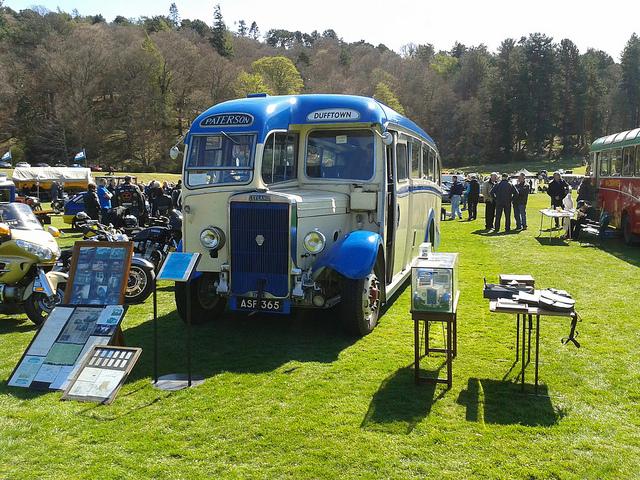What event is this?
Short answer required. Car show. By the way people are dressed, is the temperature cool?
Give a very brief answer. Yes. Can you tell from the license plate if the gathering is in the US?
Quick response, please. No. 